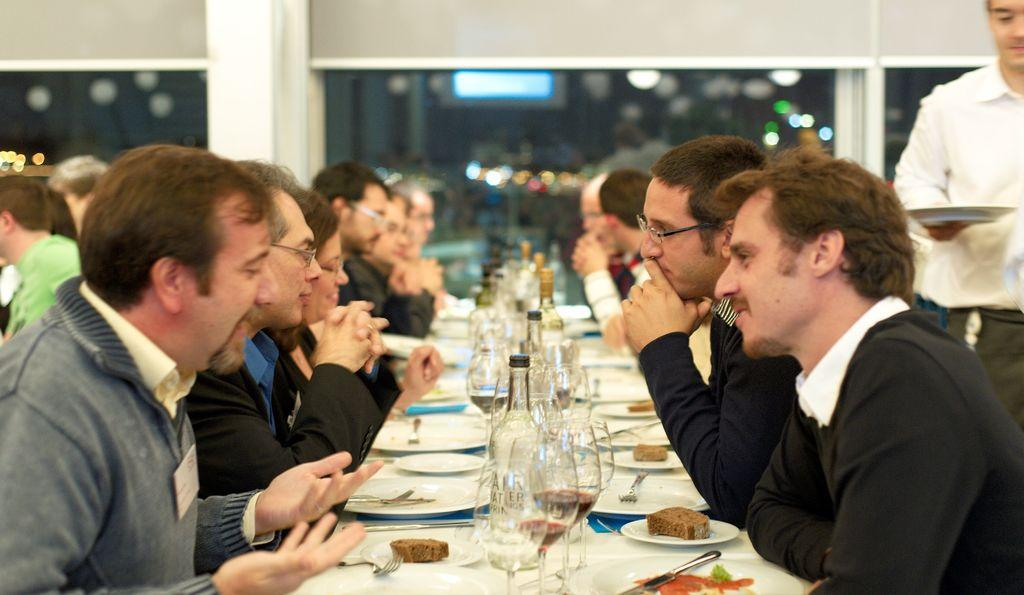What is happening in the image? There are people sitting on either side of a table. What is on the table? The table has food on it and wine bottles. Where might this scene be taking place? The setting appears to be in a restaurant. What type of development can be seen in the background of the image? There is no development visible in the background of the image; it appears to be set in a restaurant. What role does the rail play in the image? There is no rail present in the image. 